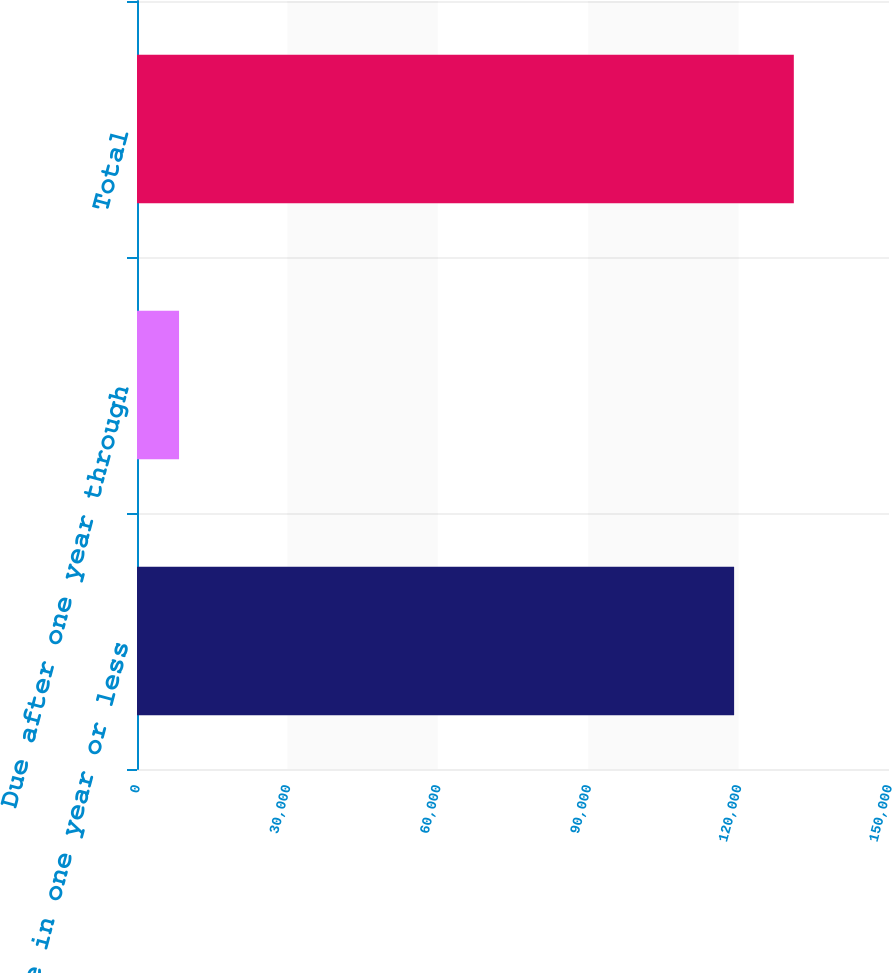<chart> <loc_0><loc_0><loc_500><loc_500><bar_chart><fcel>Due in one year or less<fcel>Due after one year through<fcel>Total<nl><fcel>119105<fcel>8387<fcel>131016<nl></chart> 